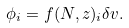<formula> <loc_0><loc_0><loc_500><loc_500>\phi _ { i } = f ( N , z ) _ { i } \delta v .</formula> 